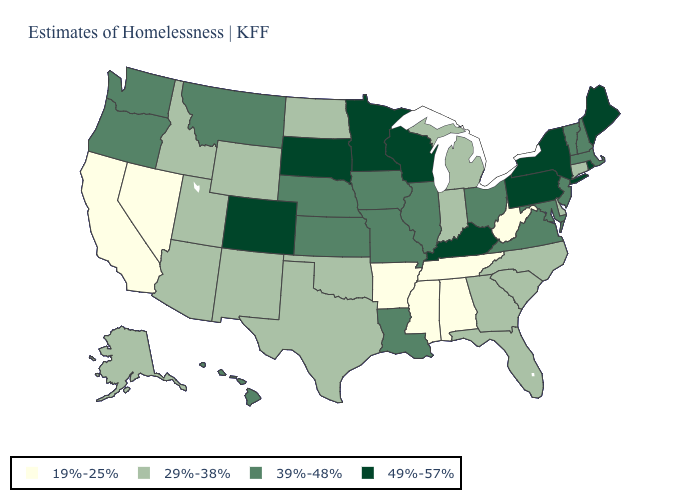Does Indiana have the same value as Wyoming?
Quick response, please. Yes. How many symbols are there in the legend?
Be succinct. 4. What is the value of Arkansas?
Short answer required. 19%-25%. What is the value of Kentucky?
Quick response, please. 49%-57%. Which states hav the highest value in the Northeast?
Quick response, please. Maine, New York, Pennsylvania, Rhode Island. Which states have the lowest value in the MidWest?
Short answer required. Indiana, Michigan, North Dakota. What is the highest value in states that border New Hampshire?
Write a very short answer. 49%-57%. Name the states that have a value in the range 29%-38%?
Quick response, please. Alaska, Arizona, Connecticut, Delaware, Florida, Georgia, Idaho, Indiana, Michigan, New Mexico, North Carolina, North Dakota, Oklahoma, South Carolina, Texas, Utah, Wyoming. How many symbols are there in the legend?
Write a very short answer. 4. Which states have the highest value in the USA?
Be succinct. Colorado, Kentucky, Maine, Minnesota, New York, Pennsylvania, Rhode Island, South Dakota, Wisconsin. Does Maryland have the lowest value in the South?
Quick response, please. No. Does New Jersey have the lowest value in the Northeast?
Answer briefly. No. What is the highest value in states that border Texas?
Concise answer only. 39%-48%. Which states have the highest value in the USA?
Answer briefly. Colorado, Kentucky, Maine, Minnesota, New York, Pennsylvania, Rhode Island, South Dakota, Wisconsin. Does Tennessee have the highest value in the USA?
Answer briefly. No. 